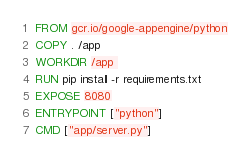Convert code to text. <code><loc_0><loc_0><loc_500><loc_500><_Dockerfile_>FROM gcr.io/google-appengine/python
COPY . /app
WORKDIR /app 
RUN pip install -r requirements.txt
EXPOSE 8080
ENTRYPOINT ["python"]
CMD ["app/server.py"]
</code> 